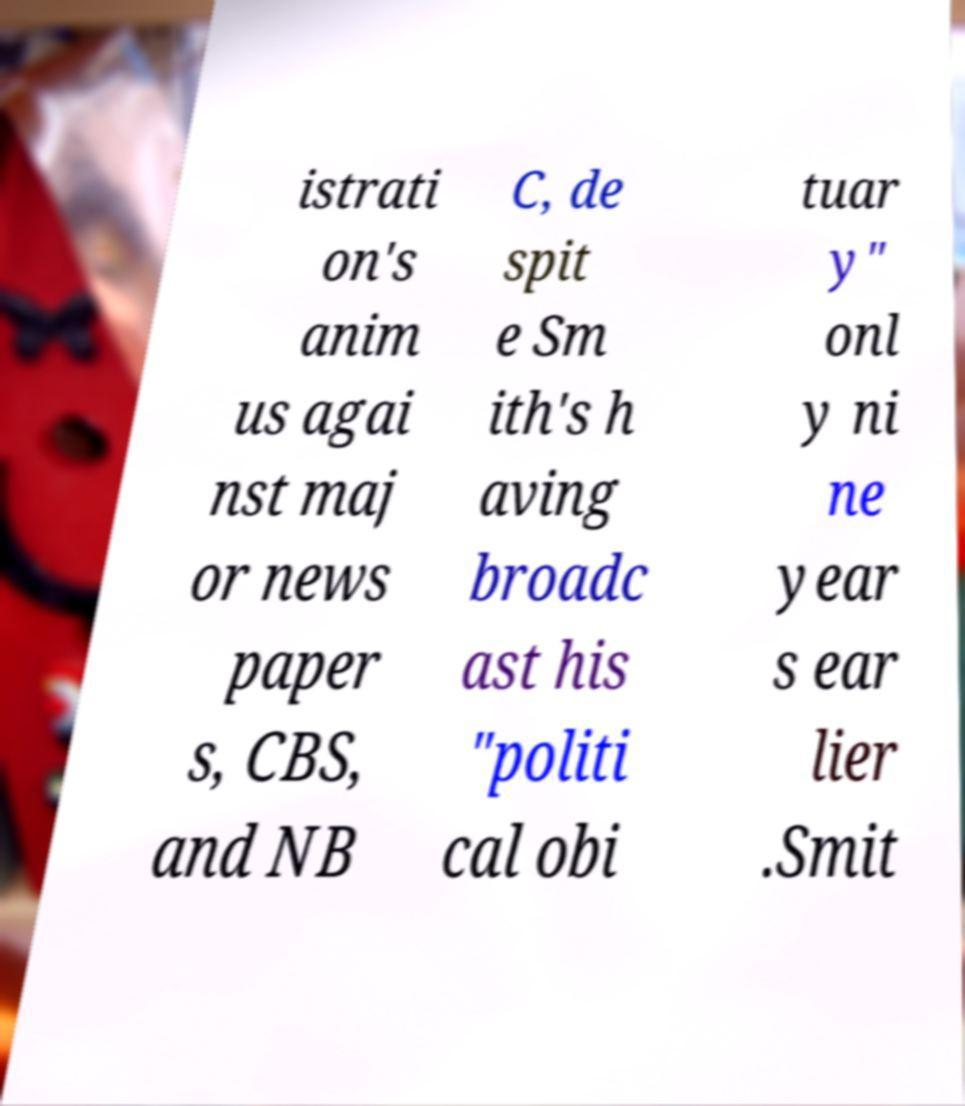Could you extract and type out the text from this image? istrati on's anim us agai nst maj or news paper s, CBS, and NB C, de spit e Sm ith's h aving broadc ast his "politi cal obi tuar y" onl y ni ne year s ear lier .Smit 